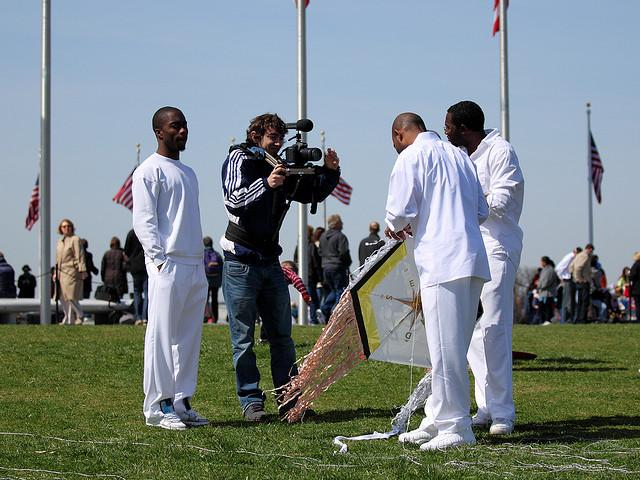What is the occupation of the man holding a camera? photographer 